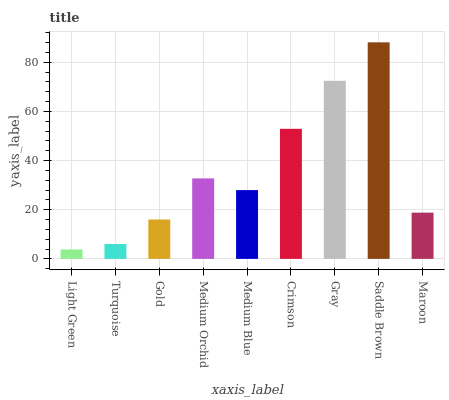Is Light Green the minimum?
Answer yes or no. Yes. Is Saddle Brown the maximum?
Answer yes or no. Yes. Is Turquoise the minimum?
Answer yes or no. No. Is Turquoise the maximum?
Answer yes or no. No. Is Turquoise greater than Light Green?
Answer yes or no. Yes. Is Light Green less than Turquoise?
Answer yes or no. Yes. Is Light Green greater than Turquoise?
Answer yes or no. No. Is Turquoise less than Light Green?
Answer yes or no. No. Is Medium Blue the high median?
Answer yes or no. Yes. Is Medium Blue the low median?
Answer yes or no. Yes. Is Maroon the high median?
Answer yes or no. No. Is Gold the low median?
Answer yes or no. No. 